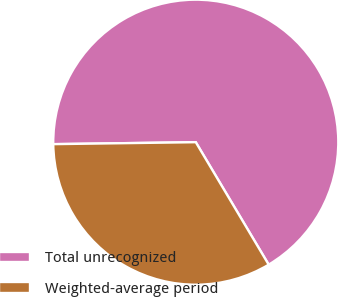Convert chart. <chart><loc_0><loc_0><loc_500><loc_500><pie_chart><fcel>Total unrecognized<fcel>Weighted-average period<nl><fcel>66.67%<fcel>33.33%<nl></chart> 